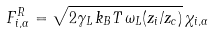Convert formula to latex. <formula><loc_0><loc_0><loc_500><loc_500>F _ { i , \alpha } ^ { R } = \sqrt { 2 \gamma _ { L } \, k _ { B } T \, \omega _ { L } ( z _ { i } / z _ { c } ) } \, \chi _ { i , \alpha }</formula> 